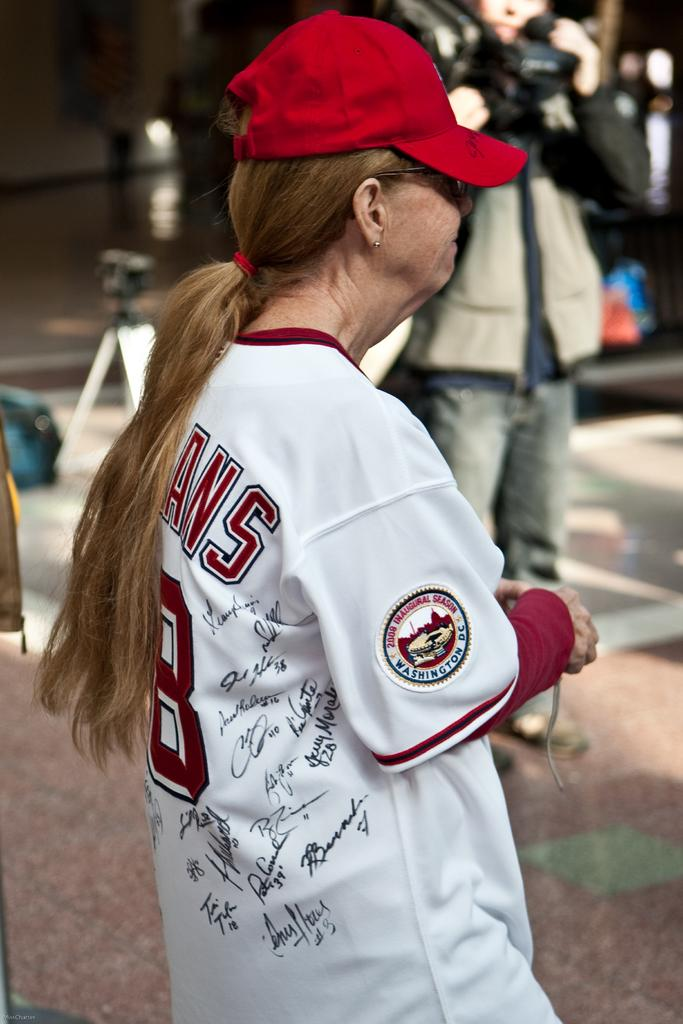Provide a one-sentence caption for the provided image. A lady wearing a signed baseball jersey for the Washington Indians. 